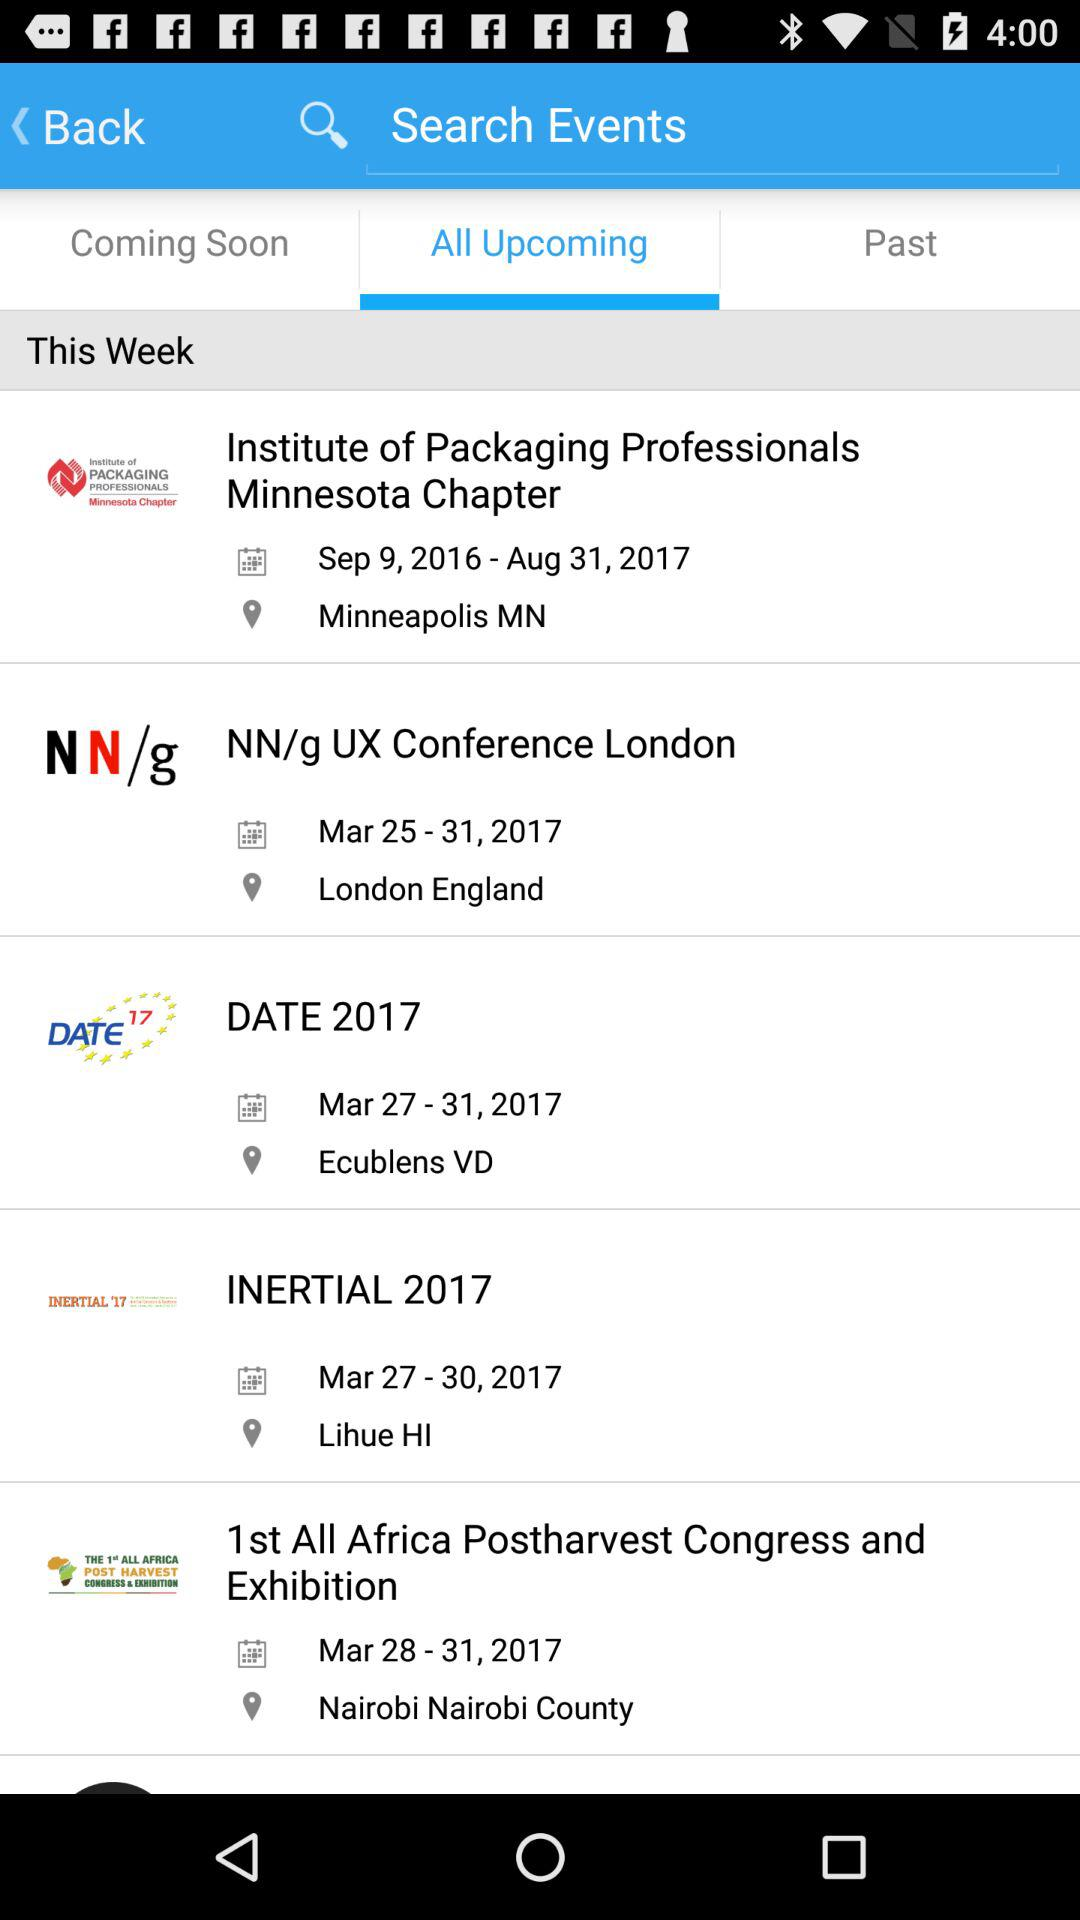Which events are in the past?
When the provided information is insufficient, respond with <no answer>. <no answer> 